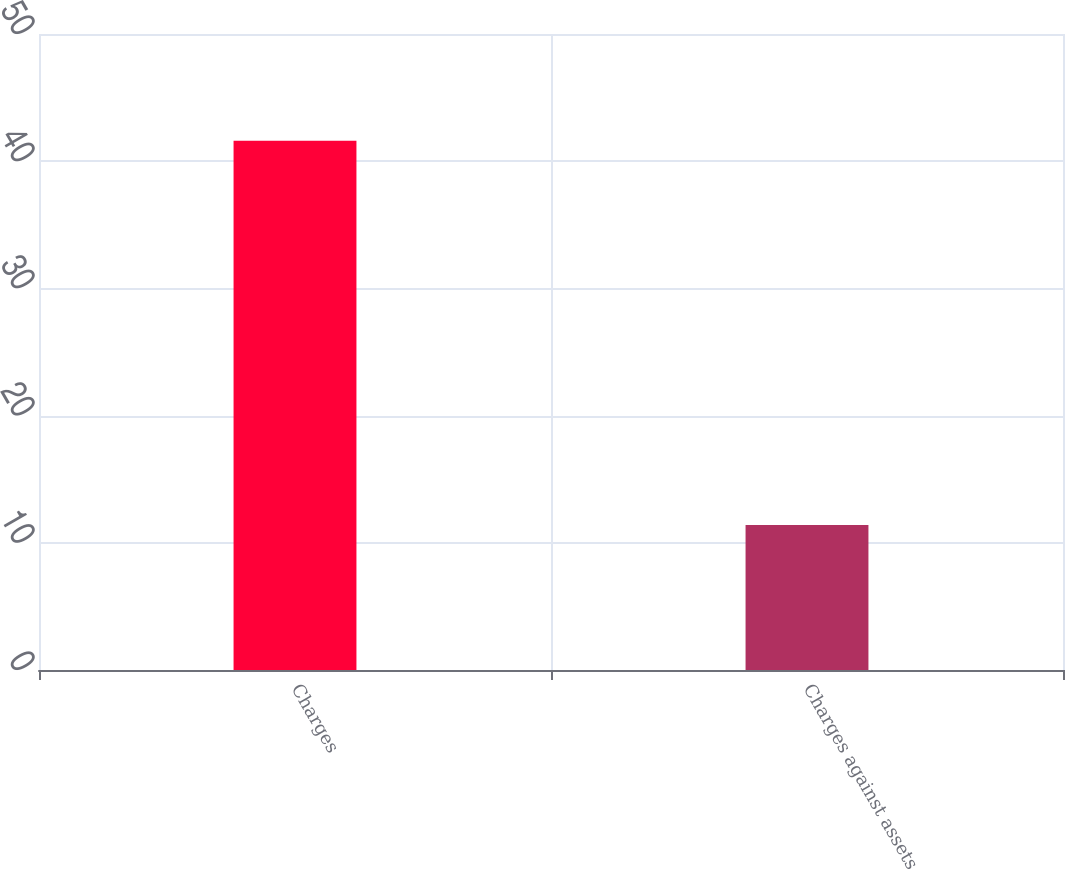Convert chart. <chart><loc_0><loc_0><loc_500><loc_500><bar_chart><fcel>Charges<fcel>Charges against assets<nl><fcel>41.6<fcel>11.4<nl></chart> 